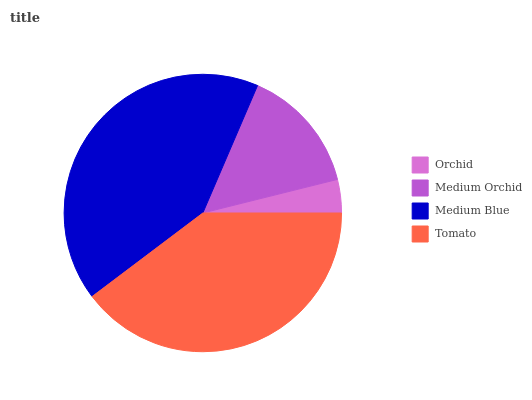Is Orchid the minimum?
Answer yes or no. Yes. Is Medium Blue the maximum?
Answer yes or no. Yes. Is Medium Orchid the minimum?
Answer yes or no. No. Is Medium Orchid the maximum?
Answer yes or no. No. Is Medium Orchid greater than Orchid?
Answer yes or no. Yes. Is Orchid less than Medium Orchid?
Answer yes or no. Yes. Is Orchid greater than Medium Orchid?
Answer yes or no. No. Is Medium Orchid less than Orchid?
Answer yes or no. No. Is Tomato the high median?
Answer yes or no. Yes. Is Medium Orchid the low median?
Answer yes or no. Yes. Is Orchid the high median?
Answer yes or no. No. Is Medium Blue the low median?
Answer yes or no. No. 